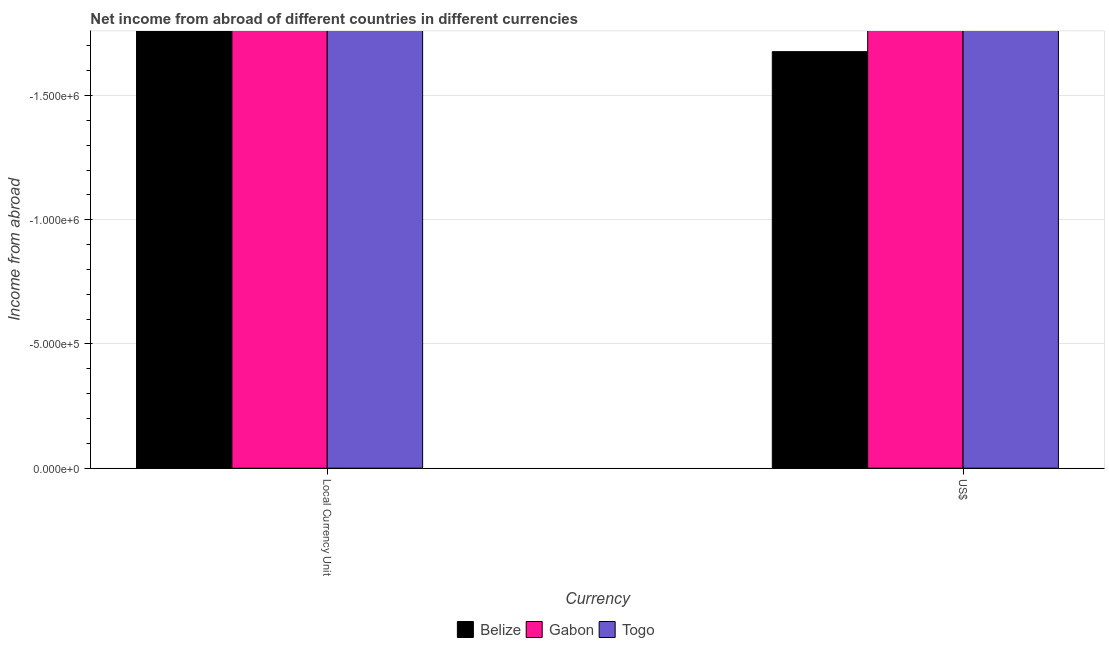How many different coloured bars are there?
Offer a very short reply. 0. Are the number of bars per tick equal to the number of legend labels?
Provide a succinct answer. No. How many bars are there on the 2nd tick from the left?
Provide a succinct answer. 0. How many bars are there on the 1st tick from the right?
Ensure brevity in your answer.  0. What is the label of the 1st group of bars from the left?
Your answer should be compact. Local Currency Unit. What is the total income from abroad in us$ in the graph?
Make the answer very short. 0. What is the average income from abroad in us$ per country?
Make the answer very short. 0. In how many countries, is the income from abroad in us$ greater than -900000 units?
Offer a very short reply. 0. In how many countries, is the income from abroad in constant 2005 us$ greater than the average income from abroad in constant 2005 us$ taken over all countries?
Offer a terse response. 0. Does the graph contain any zero values?
Provide a short and direct response. Yes. Does the graph contain grids?
Ensure brevity in your answer.  Yes. Where does the legend appear in the graph?
Give a very brief answer. Bottom center. How many legend labels are there?
Give a very brief answer. 3. How are the legend labels stacked?
Keep it short and to the point. Horizontal. What is the title of the graph?
Your response must be concise. Net income from abroad of different countries in different currencies. What is the label or title of the X-axis?
Keep it short and to the point. Currency. What is the label or title of the Y-axis?
Your answer should be compact. Income from abroad. What is the Income from abroad of Gabon in Local Currency Unit?
Keep it short and to the point. 0. What is the Income from abroad in Togo in Local Currency Unit?
Your response must be concise. 0. What is the Income from abroad in Gabon in US$?
Offer a terse response. 0. What is the Income from abroad of Togo in US$?
Make the answer very short. 0. What is the total Income from abroad of Belize in the graph?
Keep it short and to the point. 0. What is the total Income from abroad of Togo in the graph?
Your answer should be very brief. 0. What is the average Income from abroad in Belize per Currency?
Give a very brief answer. 0. What is the average Income from abroad of Gabon per Currency?
Keep it short and to the point. 0. 